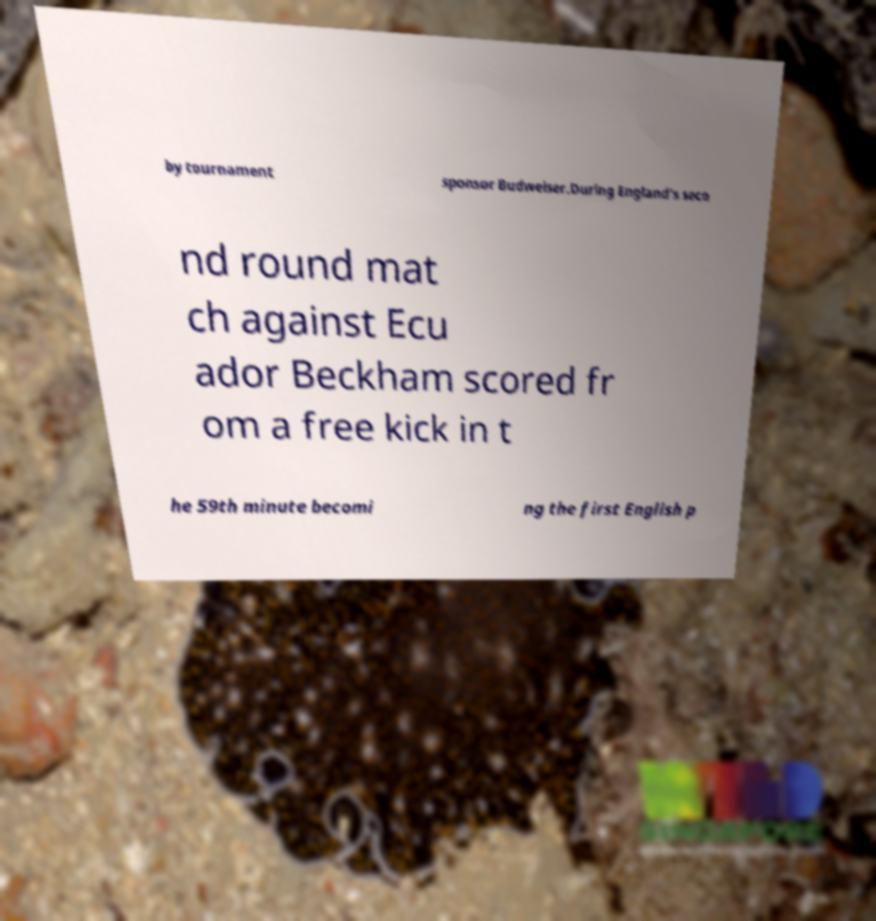Please identify and transcribe the text found in this image. by tournament sponsor Budweiser.During England's seco nd round mat ch against Ecu ador Beckham scored fr om a free kick in t he 59th minute becomi ng the first English p 